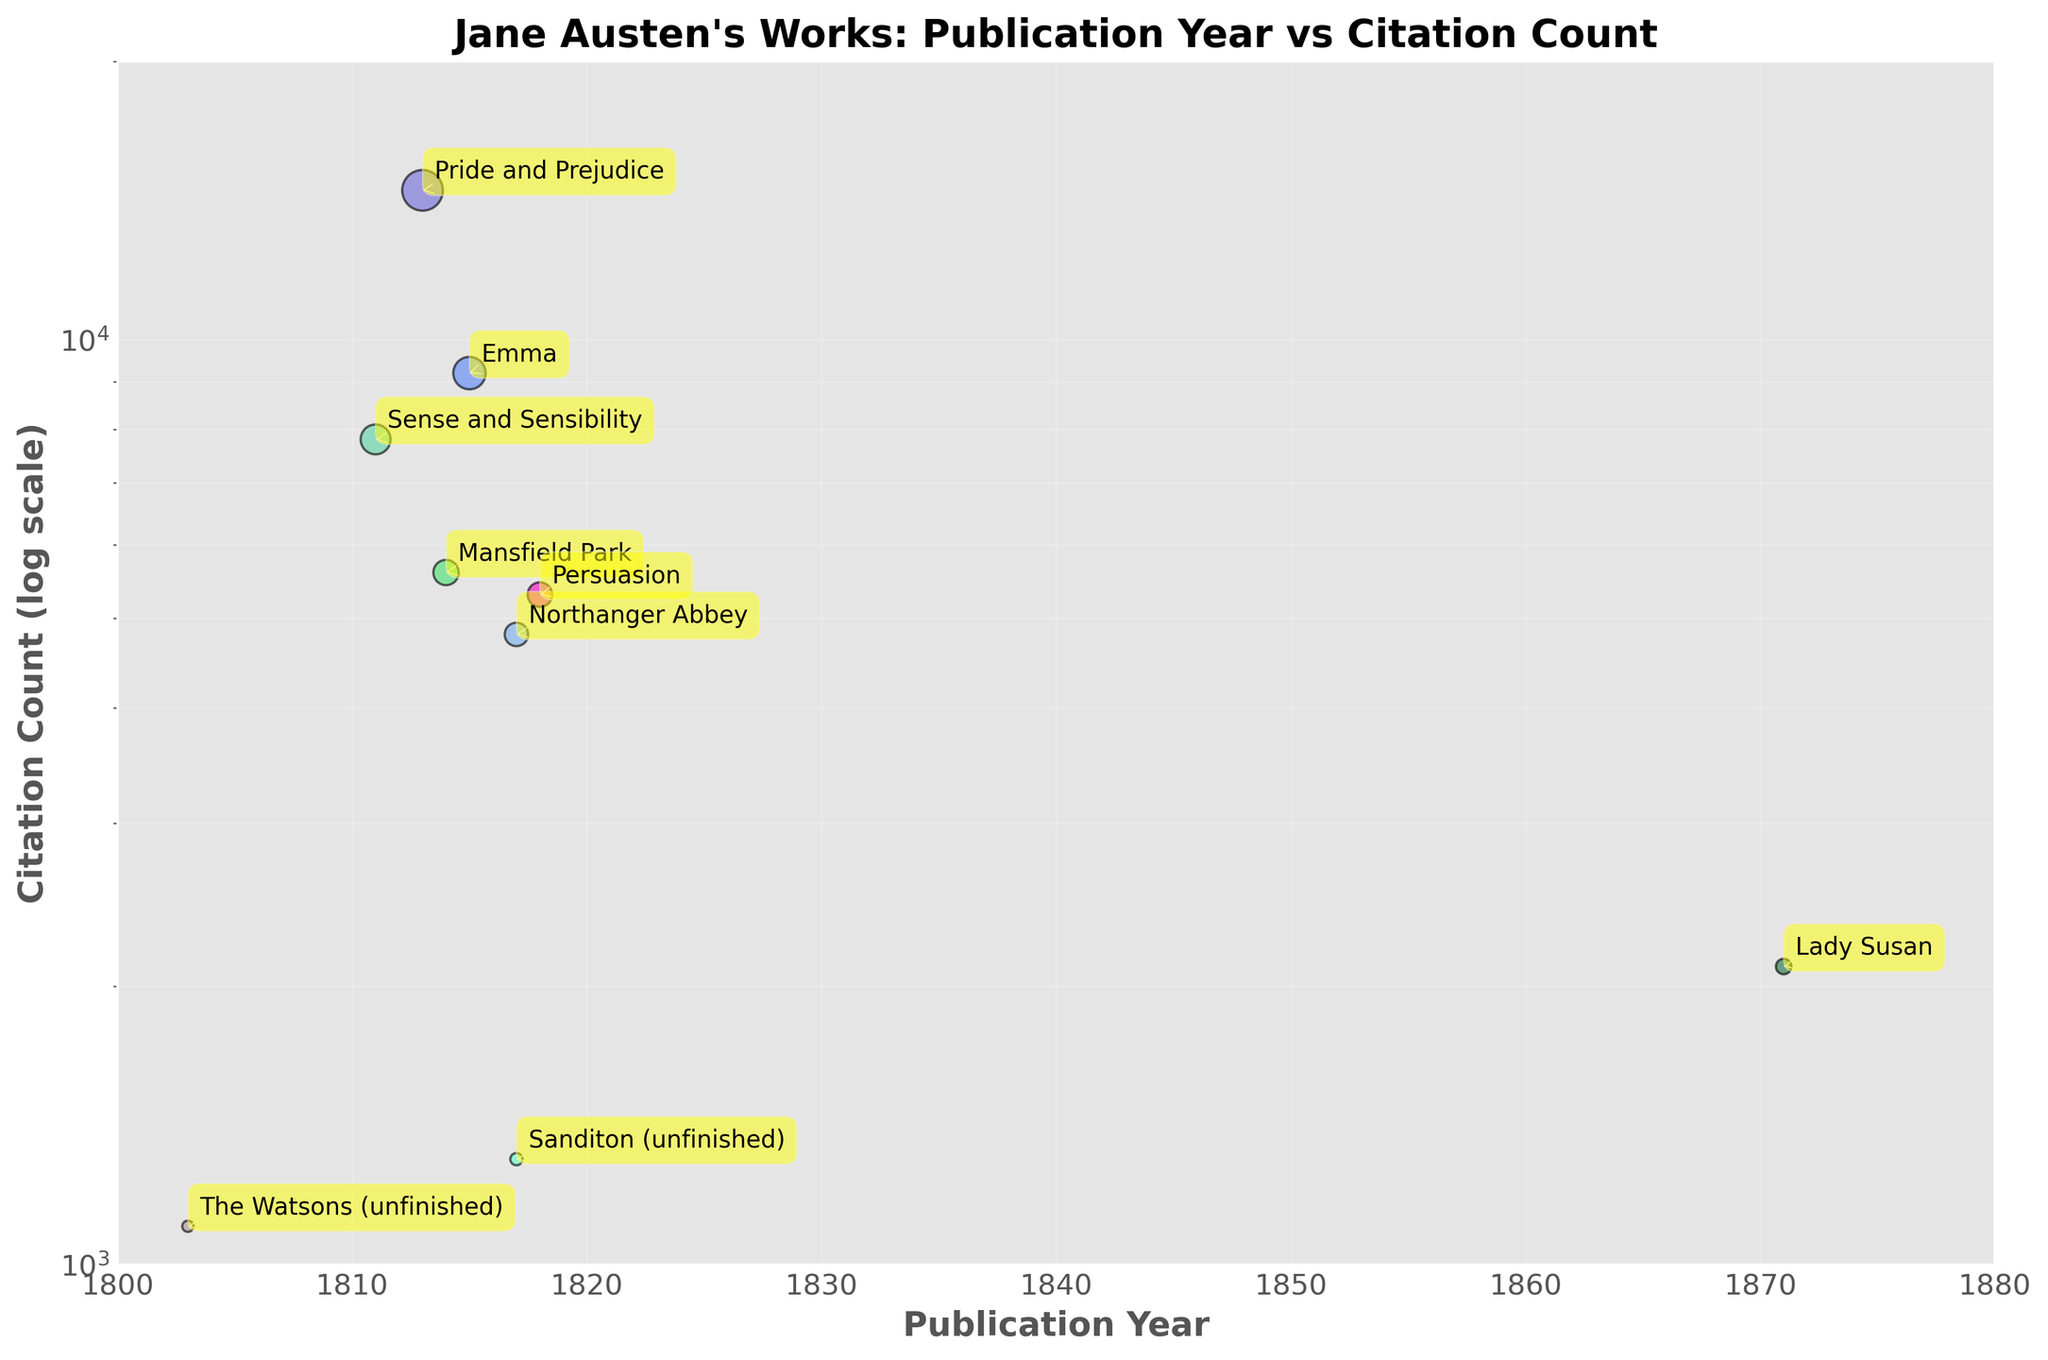Which work has the highest citation count? The plot shows the citation counts of Jane Austen's works, and the highest point on the y-axis (log scale) representing the publication with the highest citation count is clearly marked.
Answer: Pride and Prejudice What is the title and citation count of Jane Austen's work published in 1818? By looking at the year 1818 on the x-axis and finding the corresponding point on the plot, we can see the work and its citation count.
Answer: Persuasion, 5300 How many of Jane Austen's works were published after 1815? By observing the points on the plot and counting those with publication years greater than 1815, we find the titles and their respective publication years.
Answer: 3 Which work has the lowest citation count, and what year was it published? By identifying the lowest point on the y-axis (log scale) and tracing back to its x-axis value to know the year of publication.
Answer: The Watsons, 1100; 1803 Are there more works with citation counts above 5000 or below 5000? By counting the number of points above the 5000 mark and comparing them with those below the 5000 mark on the y-axis (log scale).
Answer: More below 5000 Which of Jane Austen's works published between 1811 and 1820 have over 9000 citations? We filter the points on the plot that are within the year range 1811 to 1820 and then see which have citation counts greater than 9000.
Answer: Pride and Prejudice, Emma What is the approximate difference in citation counts between 'Pride and Prejudice' and 'Sense and Sensibility'? By noting the citation counts of 'Pride and Prejudice' (14500) and 'Sense and Sensibility' (7800), and calculating the difference between them.
Answer: 6700 On what basis can we say that the citation counts are plotted on a log scale? The even spacing between the citation counts along the y-axis and notable clustering of points at lower citation values highlight the log scale.
Answer: Even spacing on log scale axis What is the range of publication years of Jane Austen's works in this plot? Observing the minimum and maximum values on the x-axis gives us the range of years.
Answer: 1803 to 1871 Considering the log scale, which work is closer in citation count to 'Emma': 'Mansfield Park' or 'Sense and Sensibility'? By comparing the relative heights on the log-scaled y-axis, we determine which work's citation count is closer to that of Emma.
Answer: Sense and Sensibility 